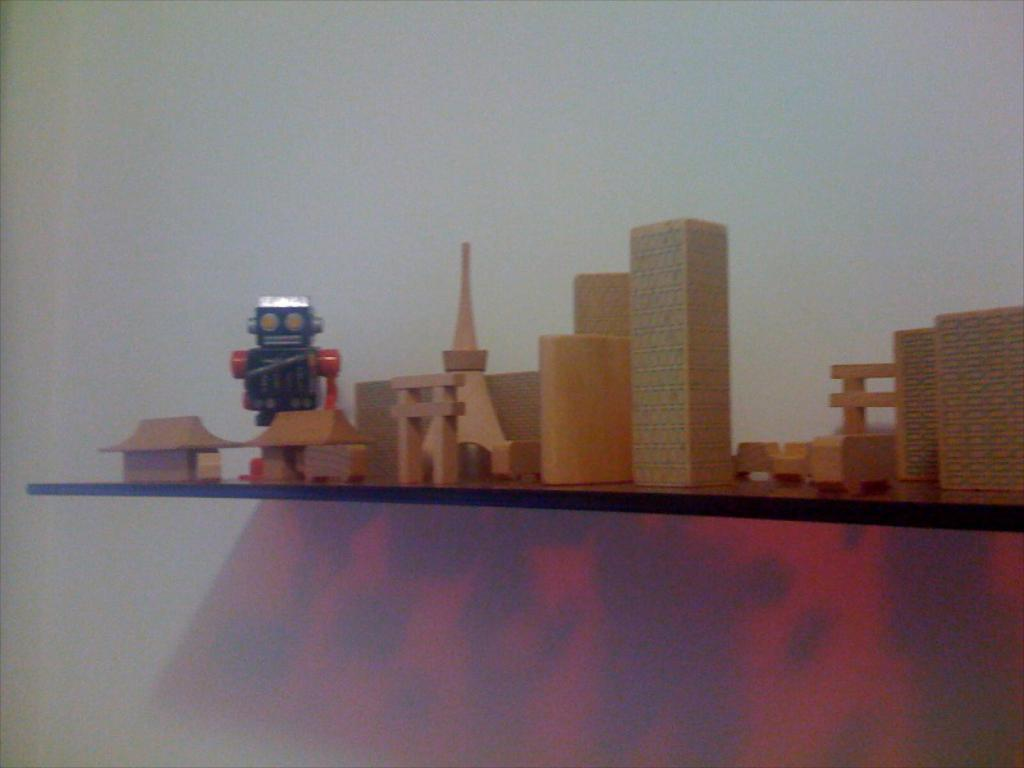What objects can be seen in the image? There are toys in the image. Where are the toys located? The toys are on a shelf. What type of leather material can be seen on the toys in the image? There is no leather material present on the toys in the image. How many clovers are visible on the shelf with the toys? There are no clovers present in the image. 